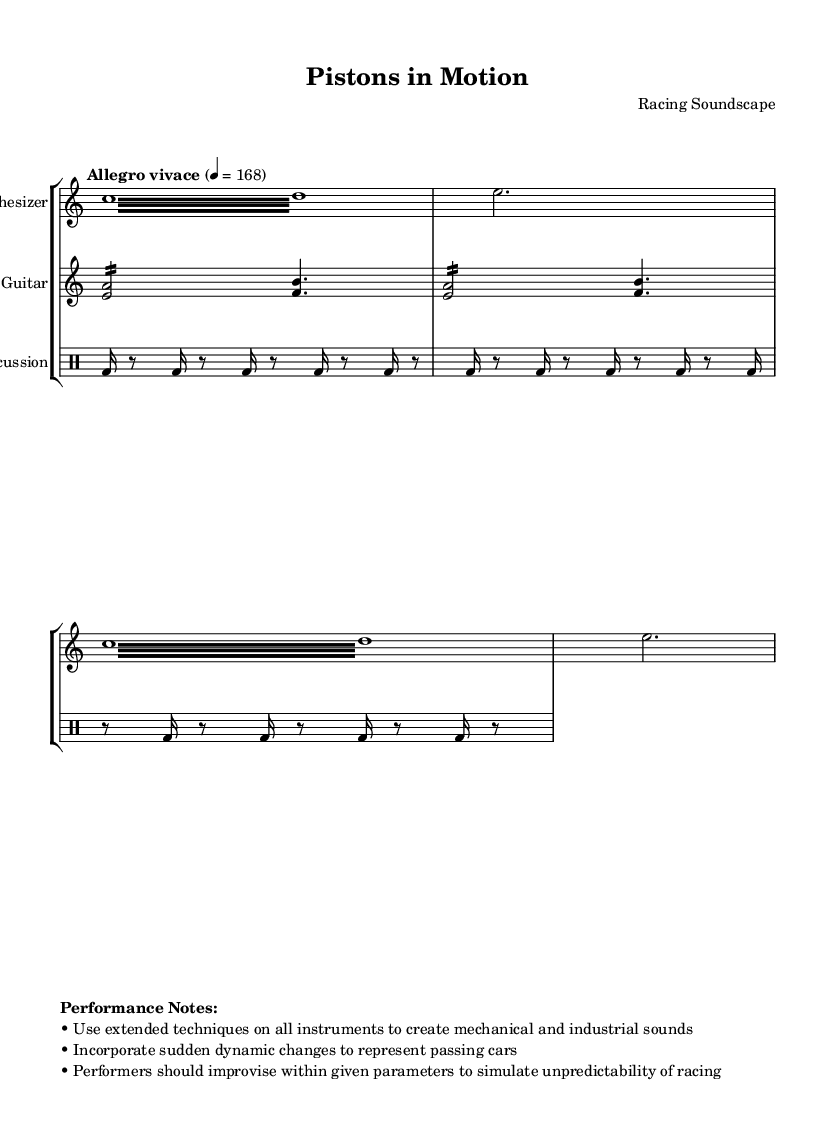What is the time signature of this music? The time signature is indicated at the beginning of the score. It is notated as 7/8, meaning there are seven eighth notes per measure.
Answer: 7/8 What is the tempo marking of this composition? The tempo marking is stated at the beginning of the piece and is marked as "Allegro vivace" with a quarter note equals 168 beats per minute.
Answer: Allegro vivace What instrument plays the synthesizer part? The synthesized part is explicitly named as "Synthesizer" in the score using the staff label.
Answer: Synthesizer How many times is the tremolo repeated in the synthesizer part? The synthesizer section includes a note that specifies to repeat the tremolo section two times, which is indicated by "repeat unfold 2".
Answer: 2 What extended techniques should performers use? The performance notes clearly state that performers should use extended techniques to create mechanical and industrial sounds.
Answer: Extended techniques How is the percussion section notated? The percussion section is notated with a drum staff that includes a repeated pattern of bass drum and rests, indicated in the drummode format.
Answer: Drum staff What should performers incorporate to simulate unpredictability? The performance notes demand that performers incorporate sudden dynamic changes to represent the unpredictability similar to passing cars during a race.
Answer: Sudden dynamic changes 